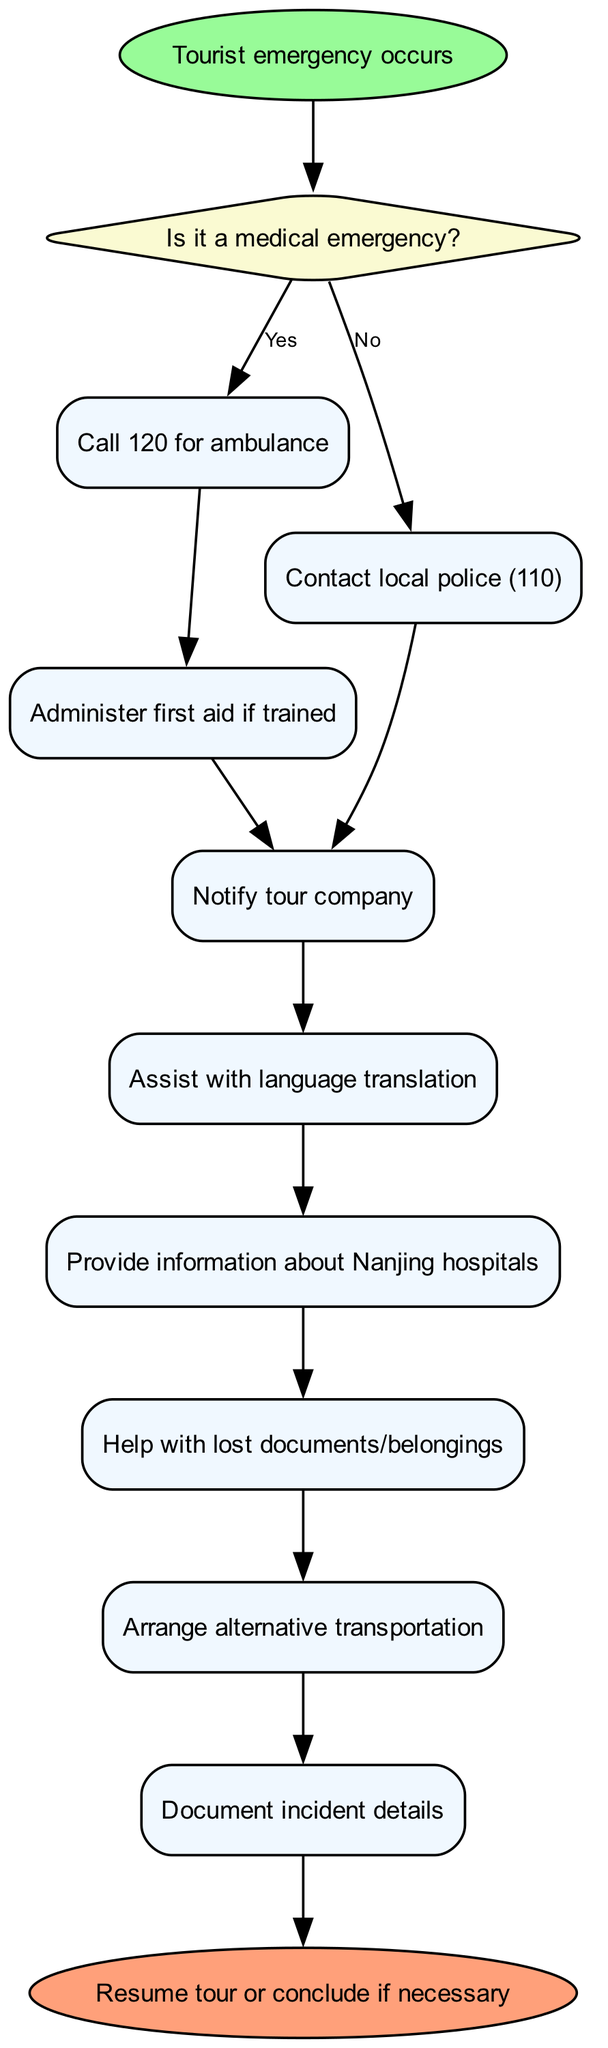What is the first step when a tourist emergency occurs? The diagram begins with the node "Tourist emergency occurs," indicating that this is the starting point of the process when an emergency arises.
Answer: Tourist emergency occurs How many process nodes are there in the diagram? The diagram includes a total of 9 process nodes, which are connected to specific actions that follow the decision point regarding whether it is a medical emergency or not.
Answer: 9 What do you do if it is a medical emergency? The flow diagram shows that the immediate action for a medical emergency is to "Call 120 for ambulance," which is the first process node linked from the decision.
Answer: Call 120 for ambulance What follows after administering first aid if trained? According to the diagram, after the action of "Administer first aid if trained," the next process step is "Contact local police (110)," illustrating the sequence of actions to be taken.
Answer: Contact local police (110) What is the last action taken in the flow chart? The final action in the series of steps provided by the diagram is "Resume tour or conclude if necessary," which is represented as the end point of the process flow.
Answer: Resume tour or conclude if necessary What is the relationship between the process of notifying the tour company and assisting with language translation? The diagram indicates that both "Notify tour company" and "Assist with language translation" follow the decision and process nodes for handling the situation after contacting local police, demonstrating that these are parallel actions.
Answer: Parallel actions If the decision is "No" for a medical emergency, which process do you initiate first? Following the decision node that confirms it's not a medical emergency, the first process initiated is "Contact local police (110)," as shown in the flow chart.
Answer: Contact local police (110) Which process comes immediately after providing information about Nanjing hospitals? In the flow chart, the process node that follows "Provide information about Nanjing hospitals" is "Help with lost documents/belongings," showing the sequence of steps to take.
Answer: Help with lost documents/belongings 